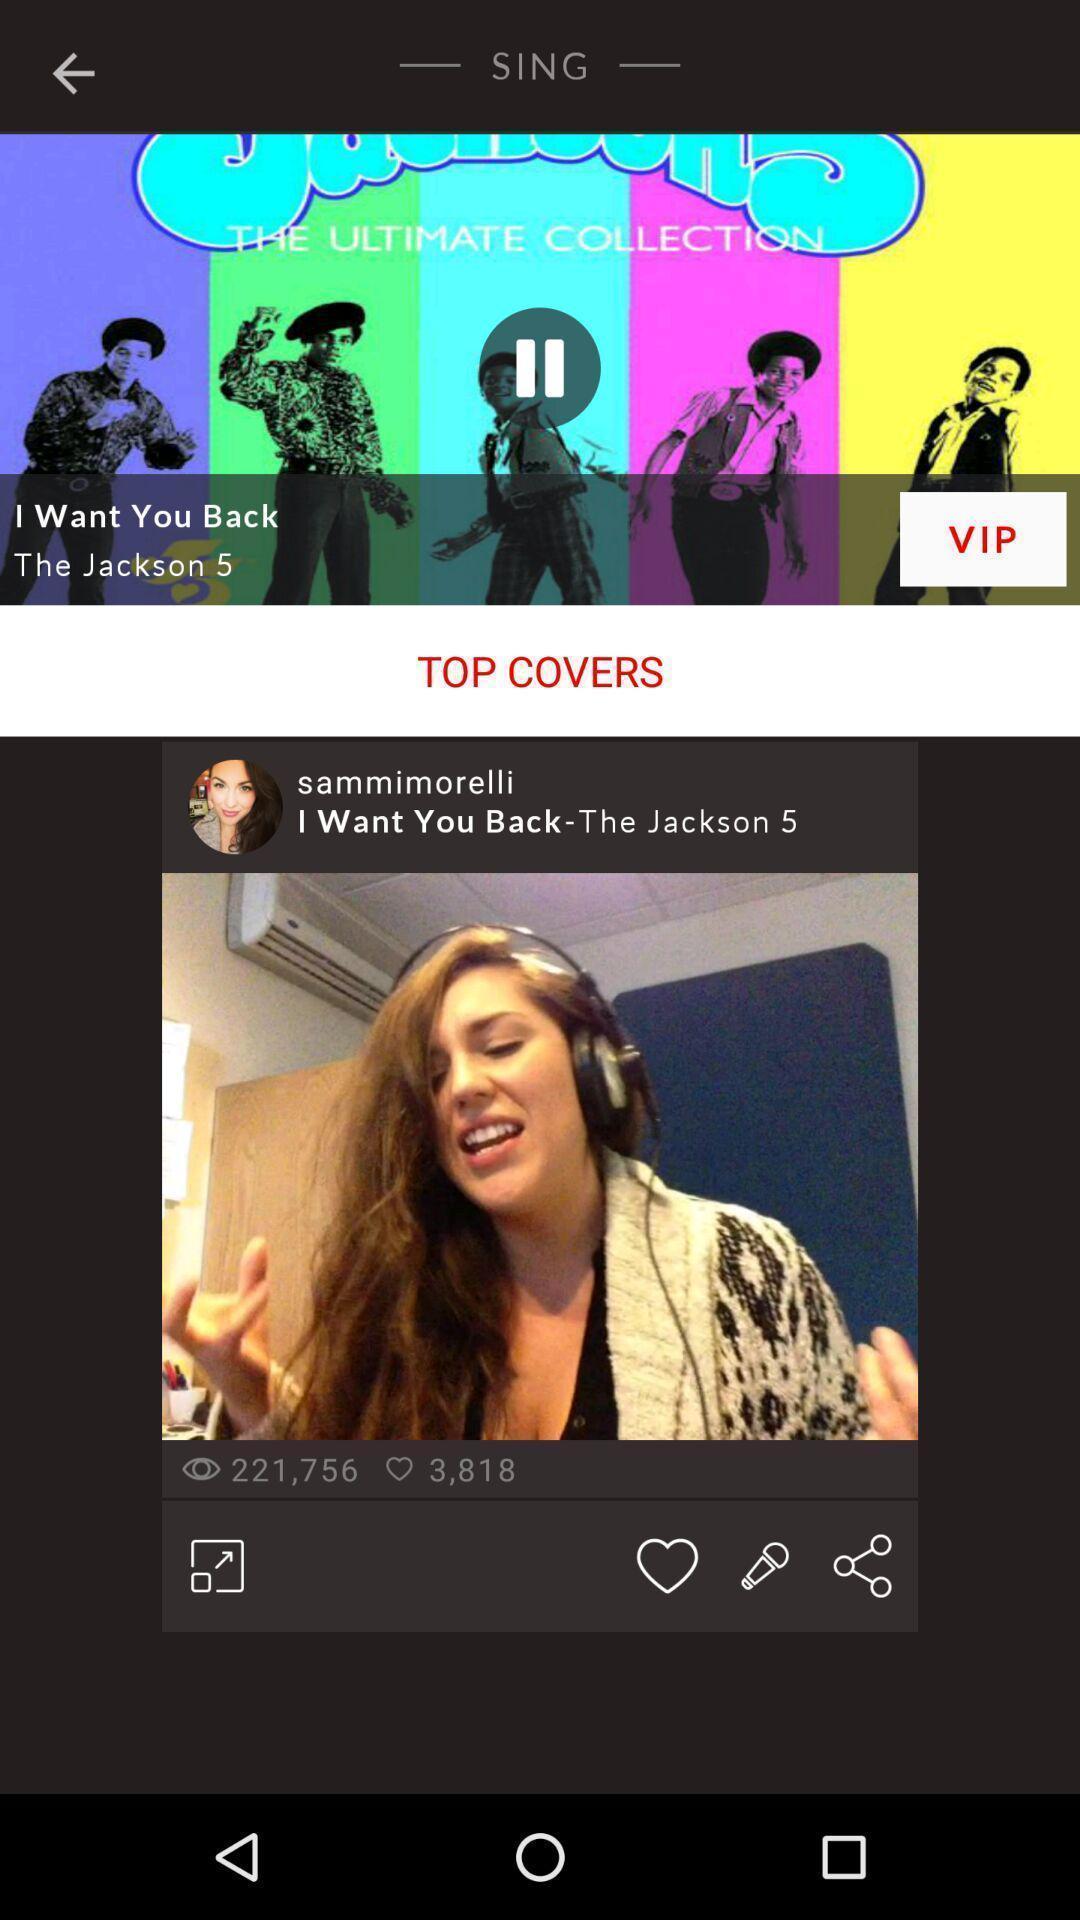Provide a description of this screenshot. Screen displaying user information in a social post. 